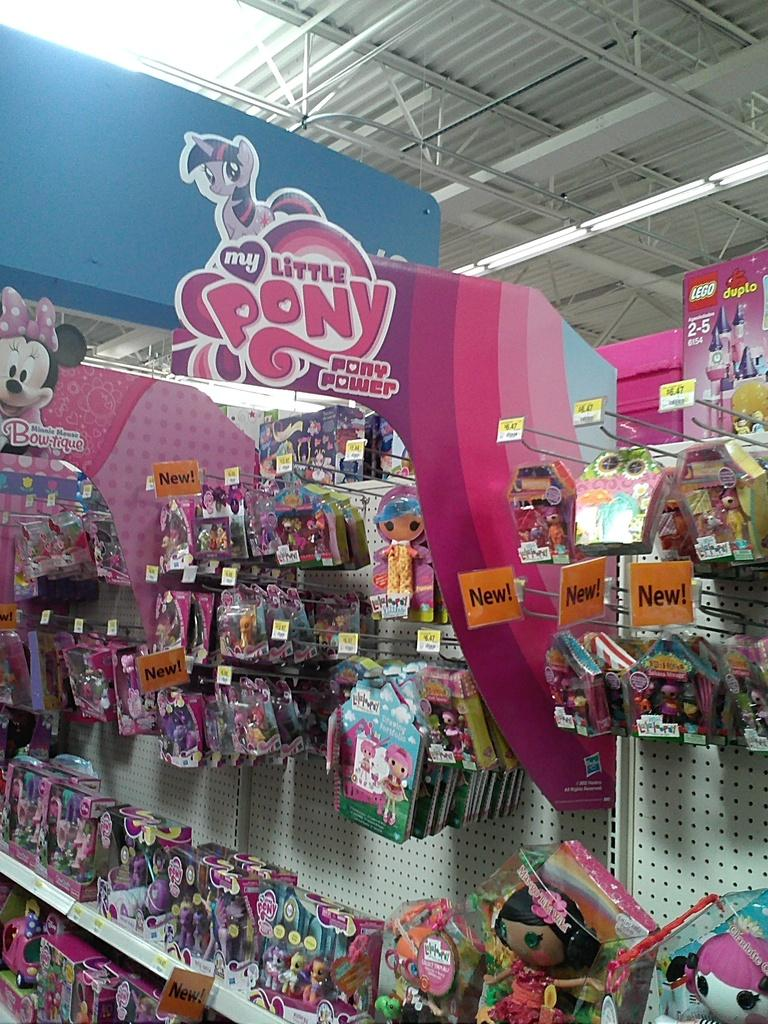<image>
Offer a succinct explanation of the picture presented. A sign reading My Little Pony is above a toy display in a store. 